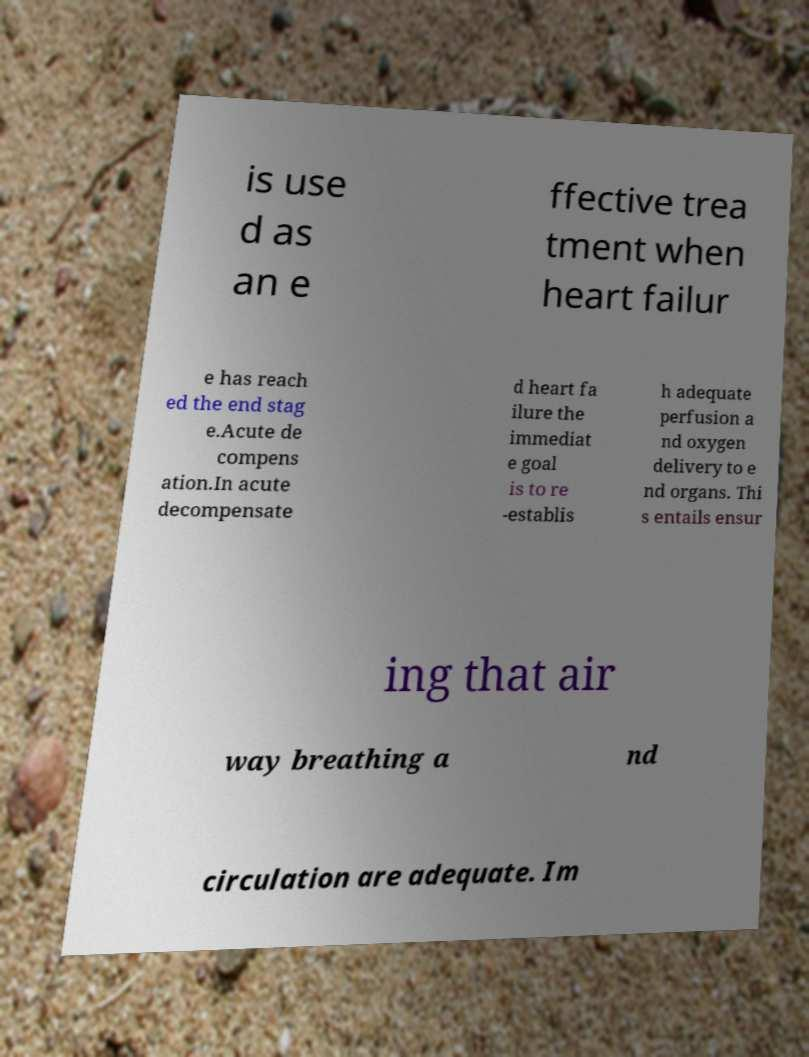There's text embedded in this image that I need extracted. Can you transcribe it verbatim? is use d as an e ffective trea tment when heart failur e has reach ed the end stag e.Acute de compens ation.In acute decompensate d heart fa ilure the immediat e goal is to re -establis h adequate perfusion a nd oxygen delivery to e nd organs. Thi s entails ensur ing that air way breathing a nd circulation are adequate. Im 